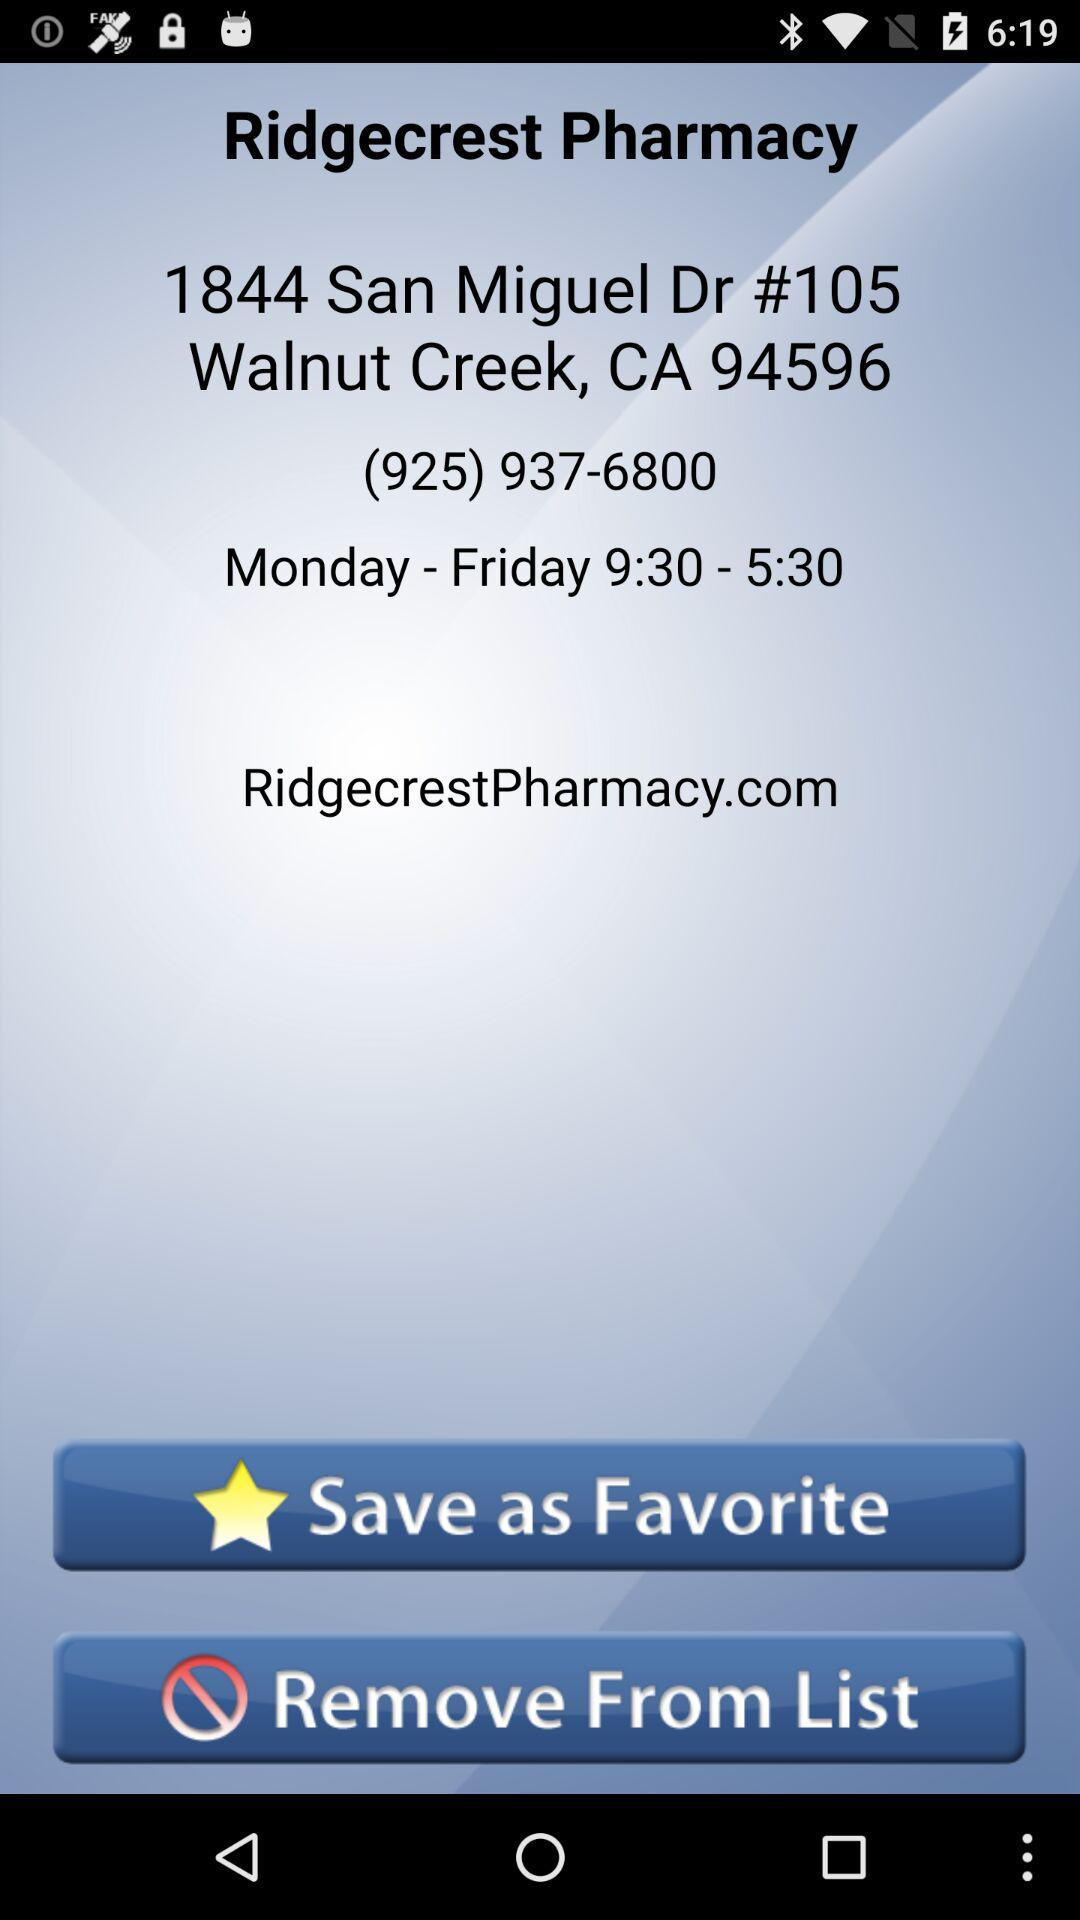How many hours does the pharmacy open for?
Answer the question using a single word or phrase. 8 